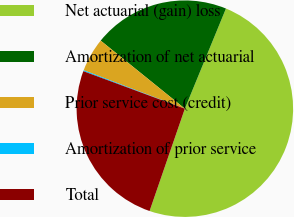Convert chart. <chart><loc_0><loc_0><loc_500><loc_500><pie_chart><fcel>Net actuarial (gain) loss<fcel>Amortization of net actuarial<fcel>Prior service cost (credit)<fcel>Amortization of prior service<fcel>Total<nl><fcel>49.09%<fcel>20.38%<fcel>5.04%<fcel>0.15%<fcel>25.35%<nl></chart> 